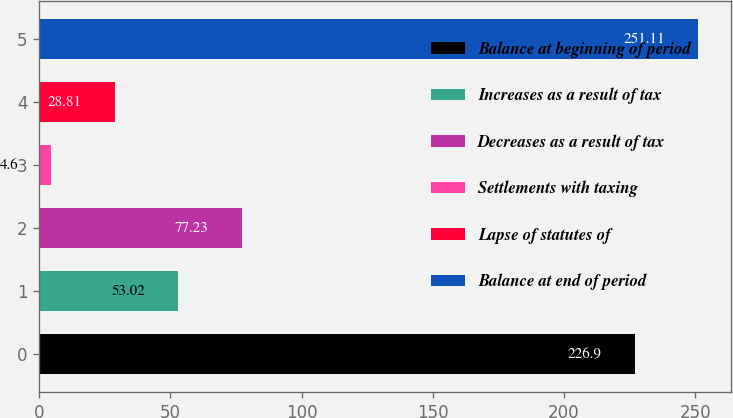<chart> <loc_0><loc_0><loc_500><loc_500><bar_chart><fcel>Balance at beginning of period<fcel>Increases as a result of tax<fcel>Decreases as a result of tax<fcel>Settlements with taxing<fcel>Lapse of statutes of<fcel>Balance at end of period<nl><fcel>226.9<fcel>53.02<fcel>77.23<fcel>4.6<fcel>28.81<fcel>251.11<nl></chart> 